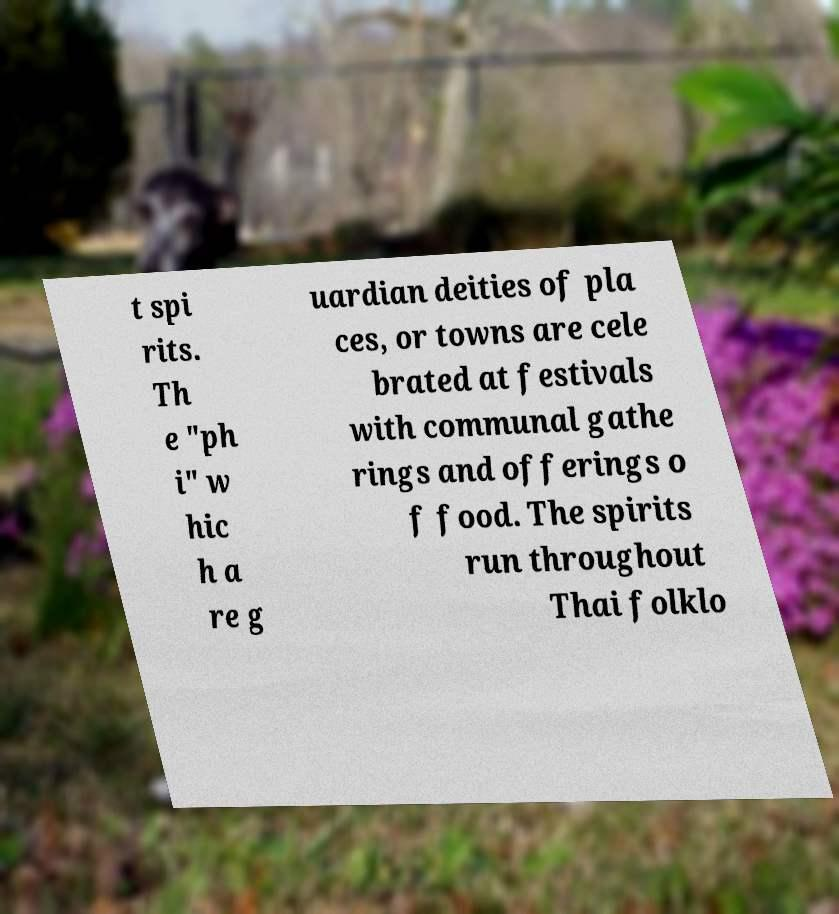For documentation purposes, I need the text within this image transcribed. Could you provide that? t spi rits. Th e "ph i" w hic h a re g uardian deities of pla ces, or towns are cele brated at festivals with communal gathe rings and offerings o f food. The spirits run throughout Thai folklo 